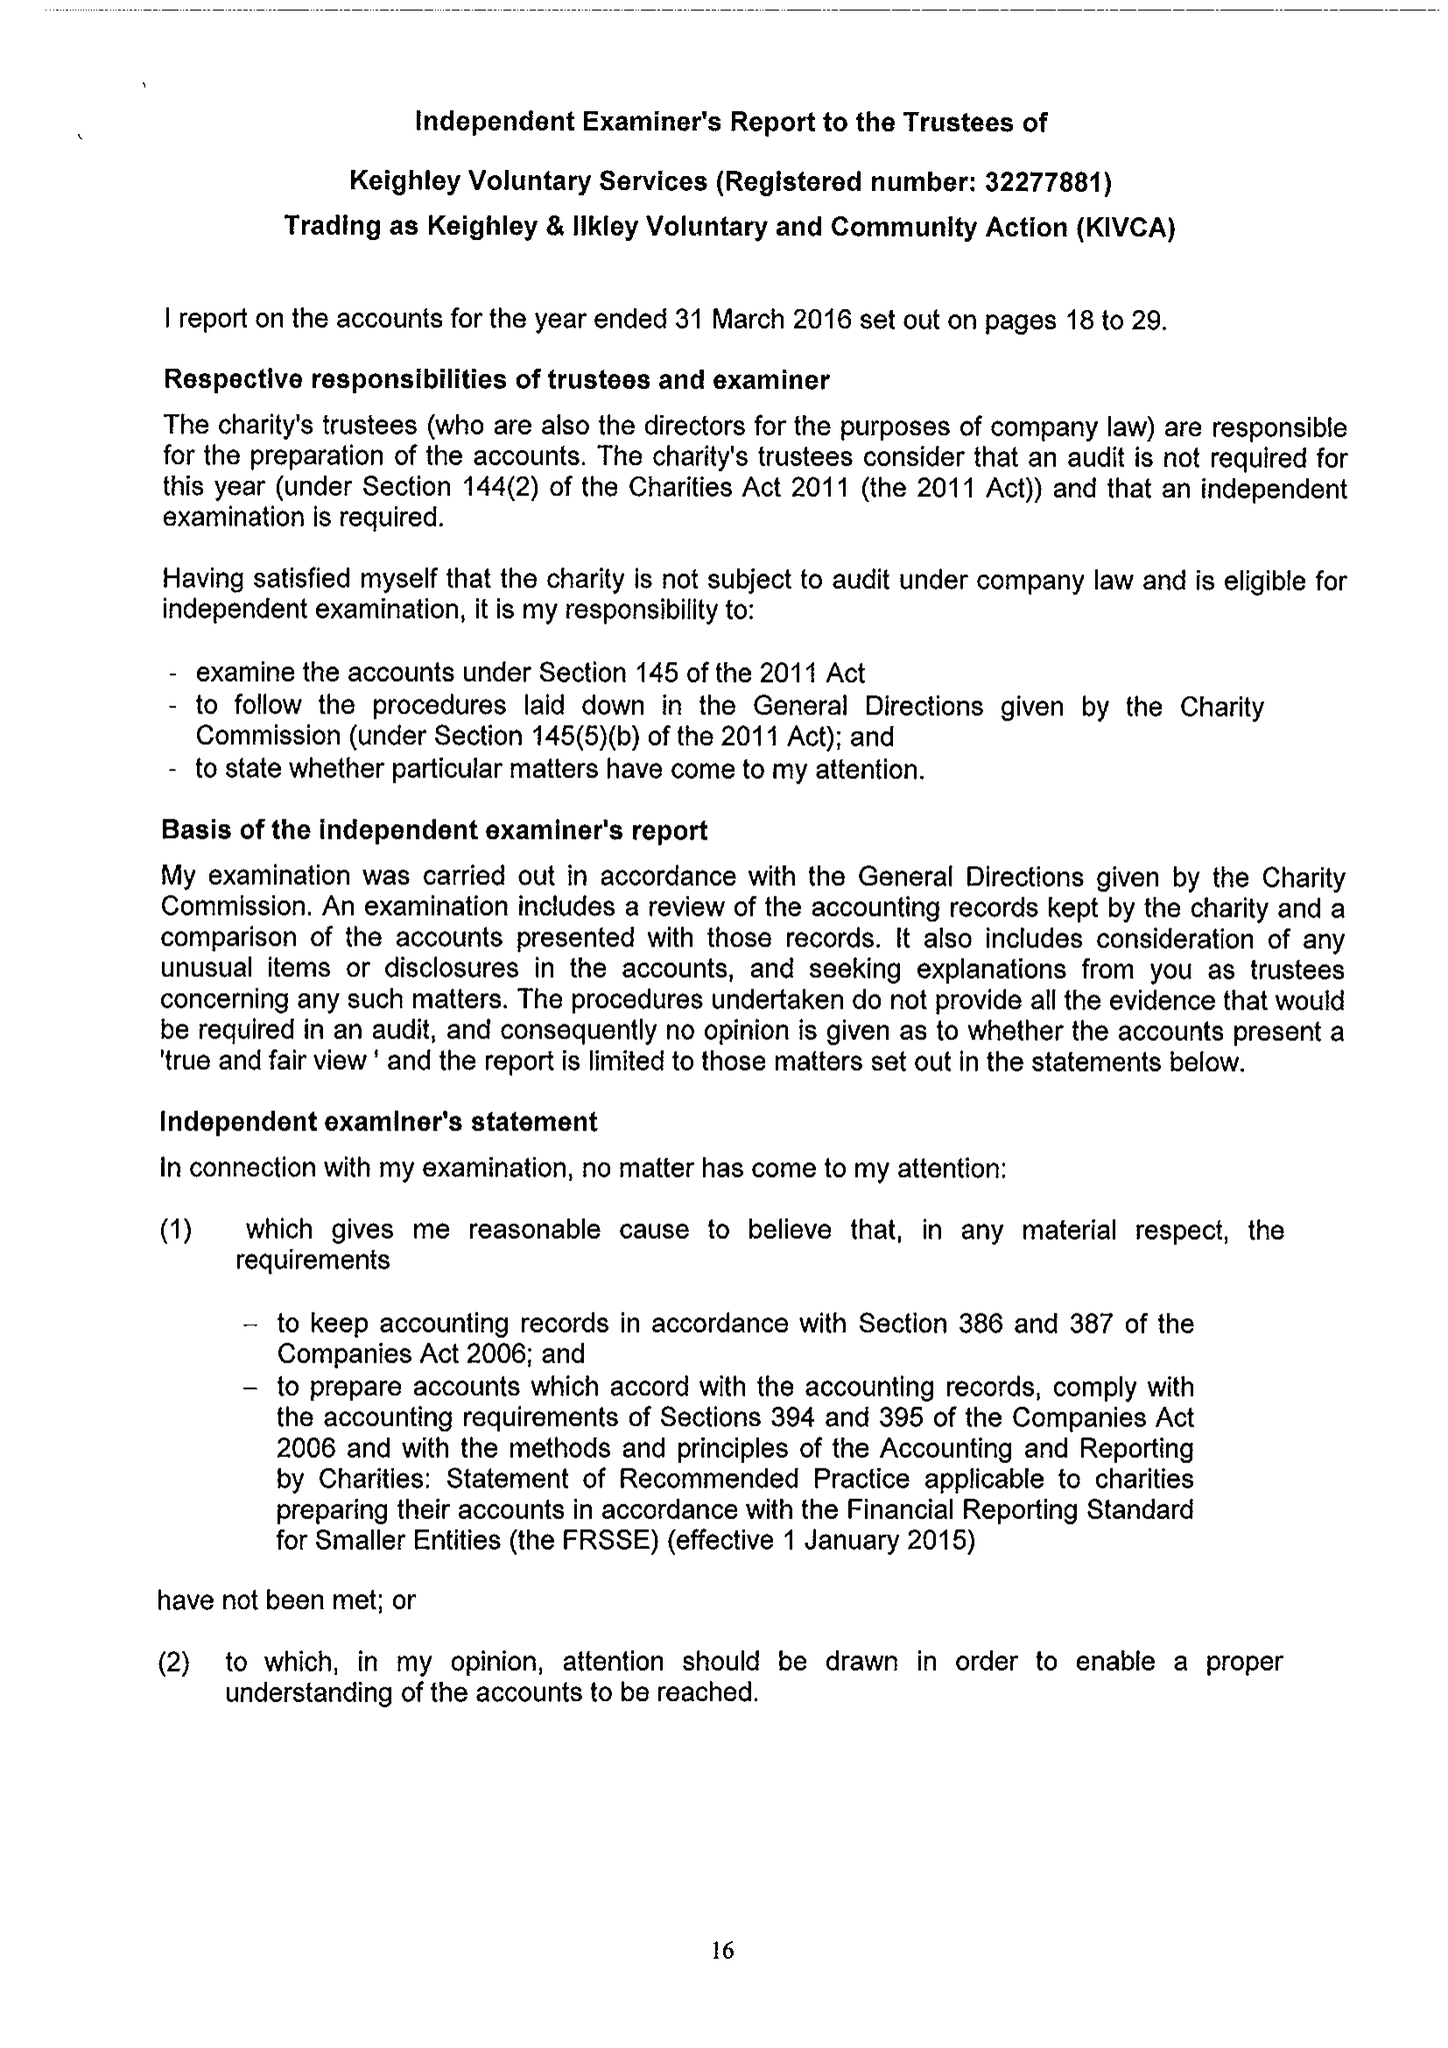What is the value for the report_date?
Answer the question using a single word or phrase. 2016-03-31 